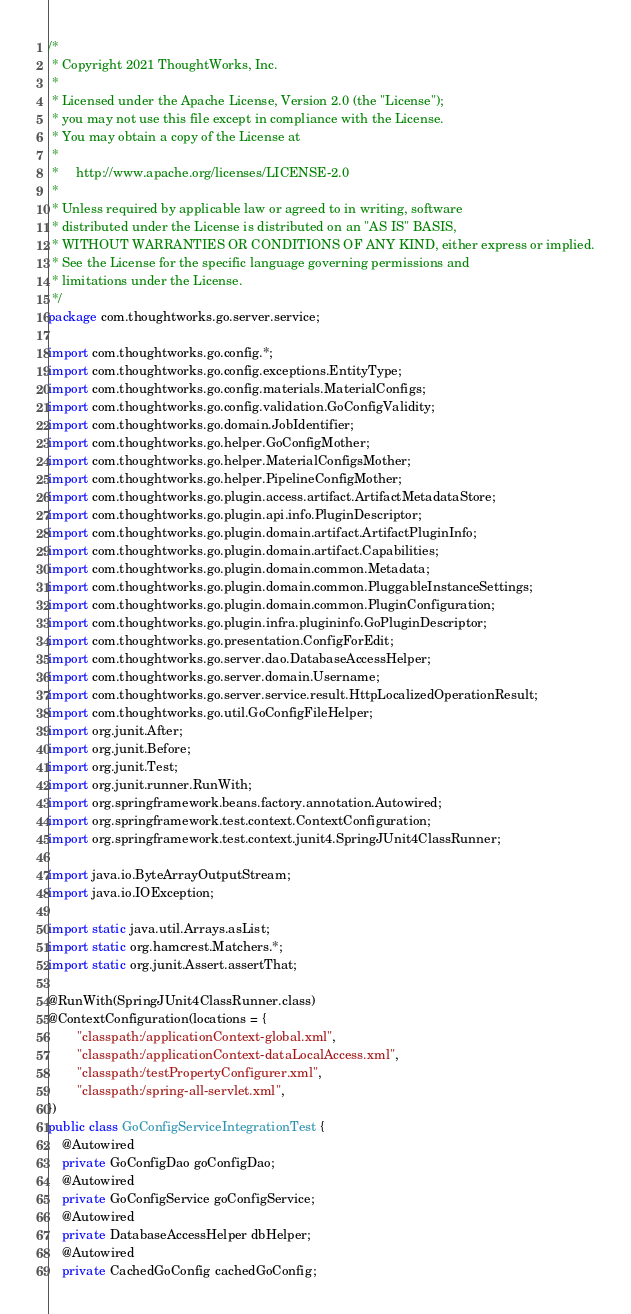<code> <loc_0><loc_0><loc_500><loc_500><_Java_>/*
 * Copyright 2021 ThoughtWorks, Inc.
 *
 * Licensed under the Apache License, Version 2.0 (the "License");
 * you may not use this file except in compliance with the License.
 * You may obtain a copy of the License at
 *
 *     http://www.apache.org/licenses/LICENSE-2.0
 *
 * Unless required by applicable law or agreed to in writing, software
 * distributed under the License is distributed on an "AS IS" BASIS,
 * WITHOUT WARRANTIES OR CONDITIONS OF ANY KIND, either express or implied.
 * See the License for the specific language governing permissions and
 * limitations under the License.
 */
package com.thoughtworks.go.server.service;

import com.thoughtworks.go.config.*;
import com.thoughtworks.go.config.exceptions.EntityType;
import com.thoughtworks.go.config.materials.MaterialConfigs;
import com.thoughtworks.go.config.validation.GoConfigValidity;
import com.thoughtworks.go.domain.JobIdentifier;
import com.thoughtworks.go.helper.GoConfigMother;
import com.thoughtworks.go.helper.MaterialConfigsMother;
import com.thoughtworks.go.helper.PipelineConfigMother;
import com.thoughtworks.go.plugin.access.artifact.ArtifactMetadataStore;
import com.thoughtworks.go.plugin.api.info.PluginDescriptor;
import com.thoughtworks.go.plugin.domain.artifact.ArtifactPluginInfo;
import com.thoughtworks.go.plugin.domain.artifact.Capabilities;
import com.thoughtworks.go.plugin.domain.common.Metadata;
import com.thoughtworks.go.plugin.domain.common.PluggableInstanceSettings;
import com.thoughtworks.go.plugin.domain.common.PluginConfiguration;
import com.thoughtworks.go.plugin.infra.plugininfo.GoPluginDescriptor;
import com.thoughtworks.go.presentation.ConfigForEdit;
import com.thoughtworks.go.server.dao.DatabaseAccessHelper;
import com.thoughtworks.go.server.domain.Username;
import com.thoughtworks.go.server.service.result.HttpLocalizedOperationResult;
import com.thoughtworks.go.util.GoConfigFileHelper;
import org.junit.After;
import org.junit.Before;
import org.junit.Test;
import org.junit.runner.RunWith;
import org.springframework.beans.factory.annotation.Autowired;
import org.springframework.test.context.ContextConfiguration;
import org.springframework.test.context.junit4.SpringJUnit4ClassRunner;

import java.io.ByteArrayOutputStream;
import java.io.IOException;

import static java.util.Arrays.asList;
import static org.hamcrest.Matchers.*;
import static org.junit.Assert.assertThat;

@RunWith(SpringJUnit4ClassRunner.class)
@ContextConfiguration(locations = {
        "classpath:/applicationContext-global.xml",
        "classpath:/applicationContext-dataLocalAccess.xml",
        "classpath:/testPropertyConfigurer.xml",
        "classpath:/spring-all-servlet.xml",
})
public class GoConfigServiceIntegrationTest {
    @Autowired
    private GoConfigDao goConfigDao;
    @Autowired
    private GoConfigService goConfigService;
    @Autowired
    private DatabaseAccessHelper dbHelper;
    @Autowired
    private CachedGoConfig cachedGoConfig;
</code> 